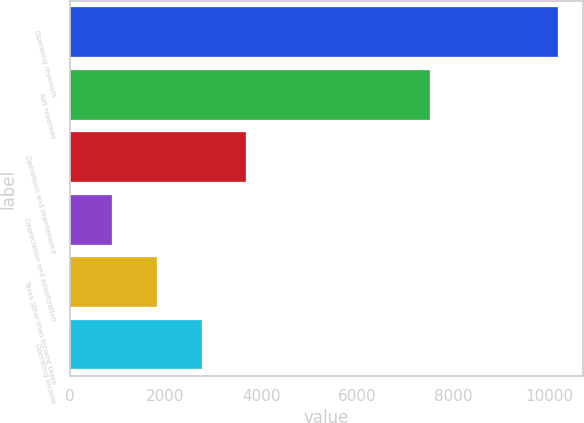<chart> <loc_0><loc_0><loc_500><loc_500><bar_chart><fcel>Operating revenues<fcel>Net revenues<fcel>Operations and maintenance<fcel>Depreciation and amortization<fcel>Taxes other than income taxes<fcel>Operating income<nl><fcel>10187<fcel>7522<fcel>3681.9<fcel>894<fcel>1823.3<fcel>2752.6<nl></chart> 